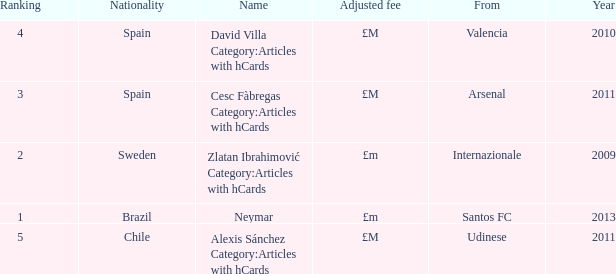Could you parse the entire table as a dict? {'header': ['Ranking', 'Nationality', 'Name', 'Adjusted fee', 'From', 'Year'], 'rows': [['4', 'Spain', 'David Villa Category:Articles with hCards', '£M', 'Valencia', '2010'], ['3', 'Spain', 'Cesc Fàbregas Category:Articles with hCards', '£M', 'Arsenal', '2011'], ['2', 'Sweden', 'Zlatan Ibrahimović Category:Articles with hCards', '£m', 'Internazionale', '2009'], ['1', 'Brazil', 'Neymar', '£m', 'Santos FC', '2013'], ['5', 'Chile', 'Alexis Sánchez Category:Articles with hCards', '£M', 'Udinese', '2011']]} What is the name of the player from Spain with a rank lower than 3? David Villa Category:Articles with hCards. 